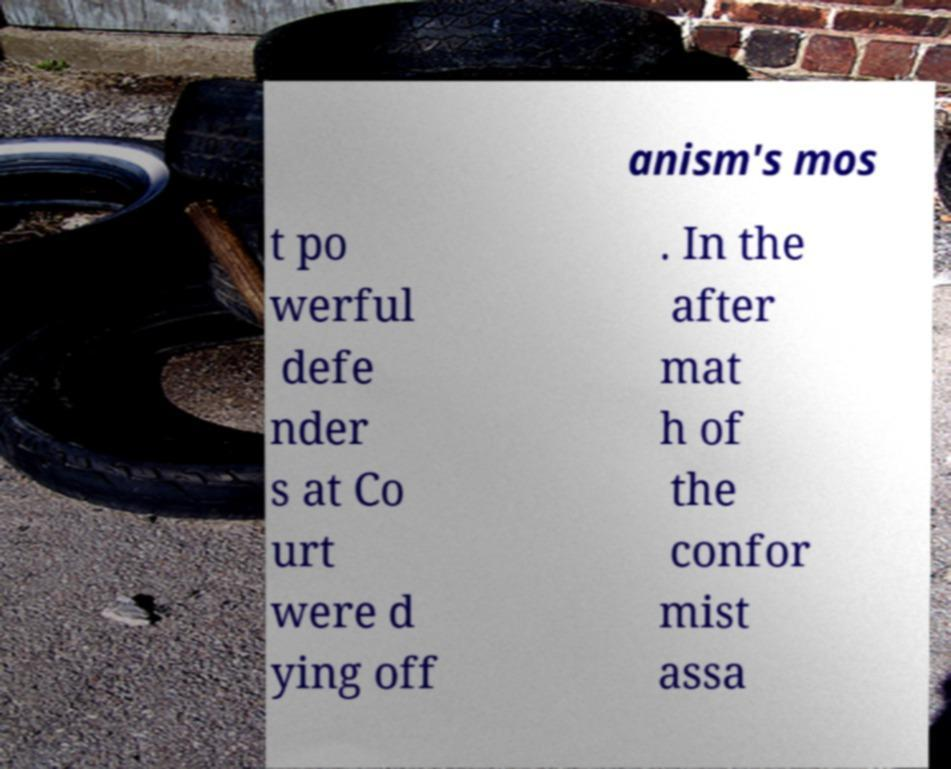For documentation purposes, I need the text within this image transcribed. Could you provide that? anism's mos t po werful defe nder s at Co urt were d ying off . In the after mat h of the confor mist assa 